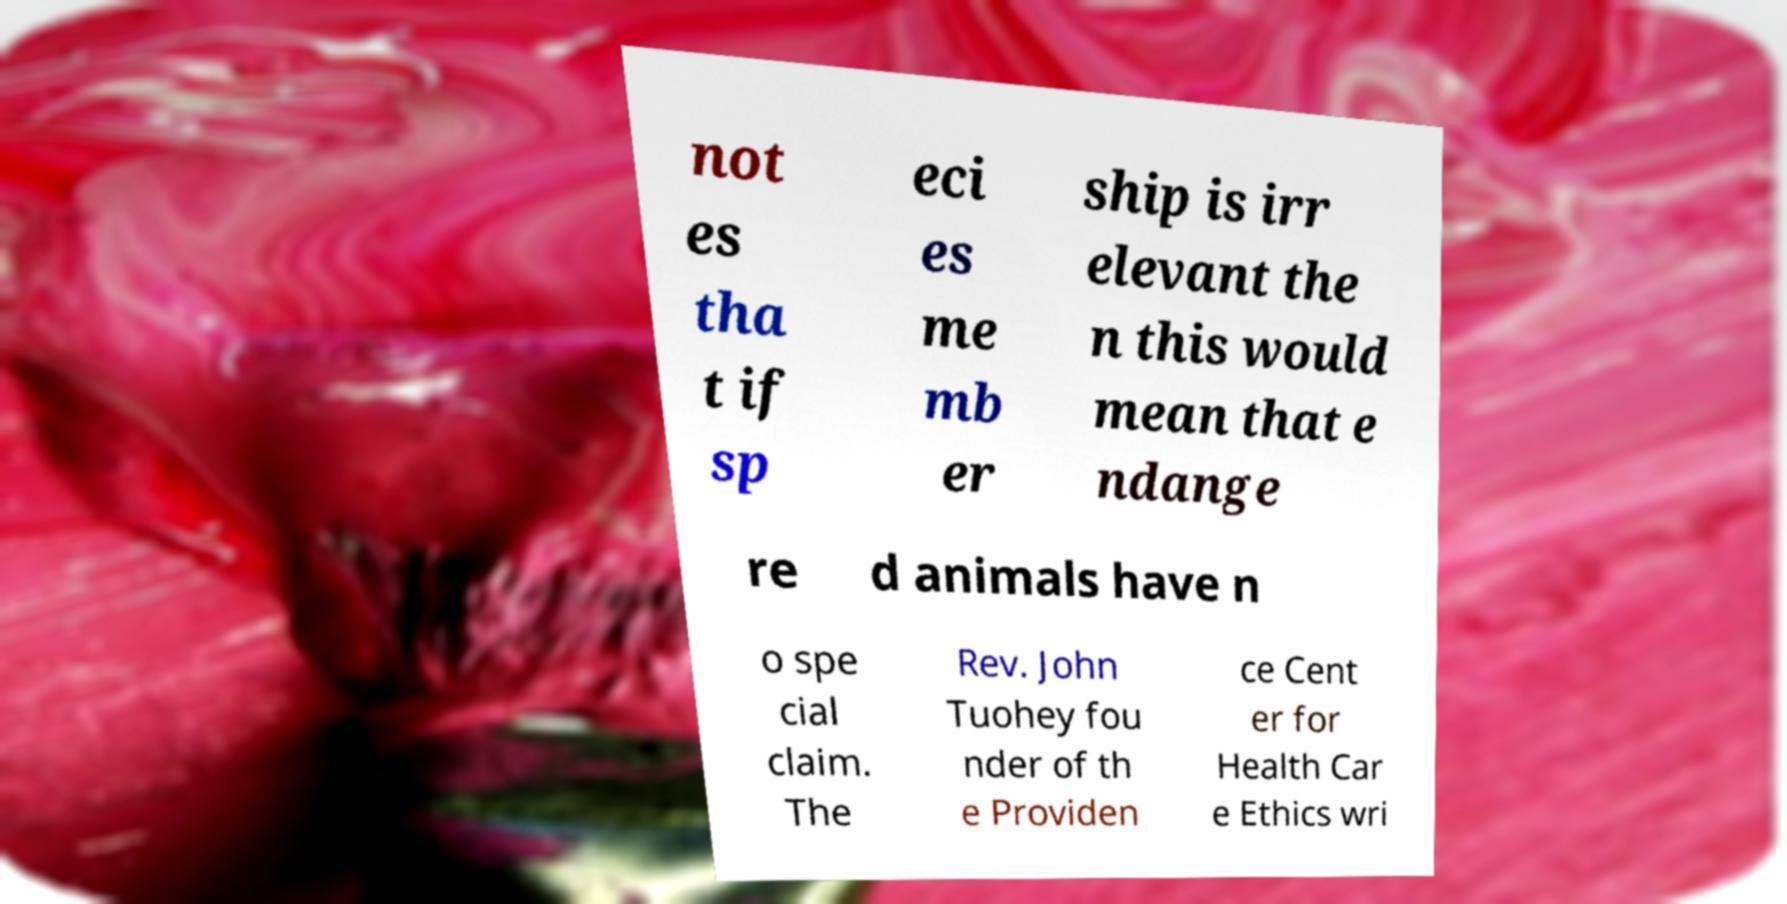For documentation purposes, I need the text within this image transcribed. Could you provide that? not es tha t if sp eci es me mb er ship is irr elevant the n this would mean that e ndange re d animals have n o spe cial claim. The Rev. John Tuohey fou nder of th e Providen ce Cent er for Health Car e Ethics wri 